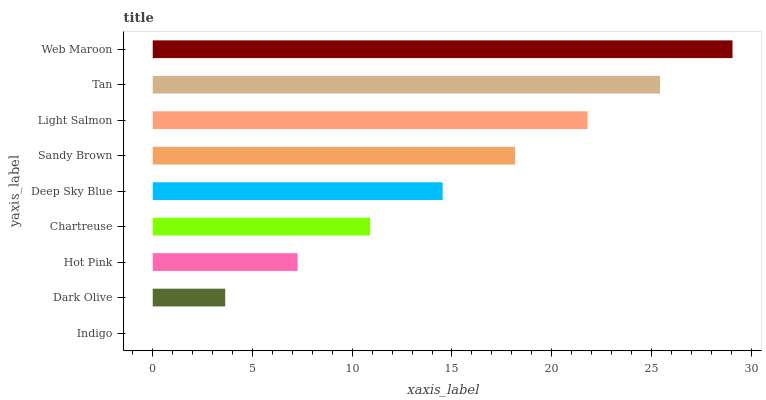Is Indigo the minimum?
Answer yes or no. Yes. Is Web Maroon the maximum?
Answer yes or no. Yes. Is Dark Olive the minimum?
Answer yes or no. No. Is Dark Olive the maximum?
Answer yes or no. No. Is Dark Olive greater than Indigo?
Answer yes or no. Yes. Is Indigo less than Dark Olive?
Answer yes or no. Yes. Is Indigo greater than Dark Olive?
Answer yes or no. No. Is Dark Olive less than Indigo?
Answer yes or no. No. Is Deep Sky Blue the high median?
Answer yes or no. Yes. Is Deep Sky Blue the low median?
Answer yes or no. Yes. Is Indigo the high median?
Answer yes or no. No. Is Tan the low median?
Answer yes or no. No. 